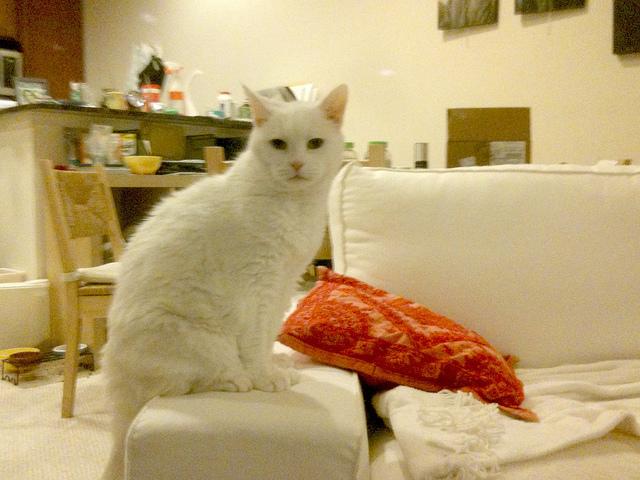How many pillows are in the photo?
Give a very brief answer. 1. Is the cat the same color as the sofa?
Give a very brief answer. Yes. What is the cat sitting on?
Keep it brief. Couch. 